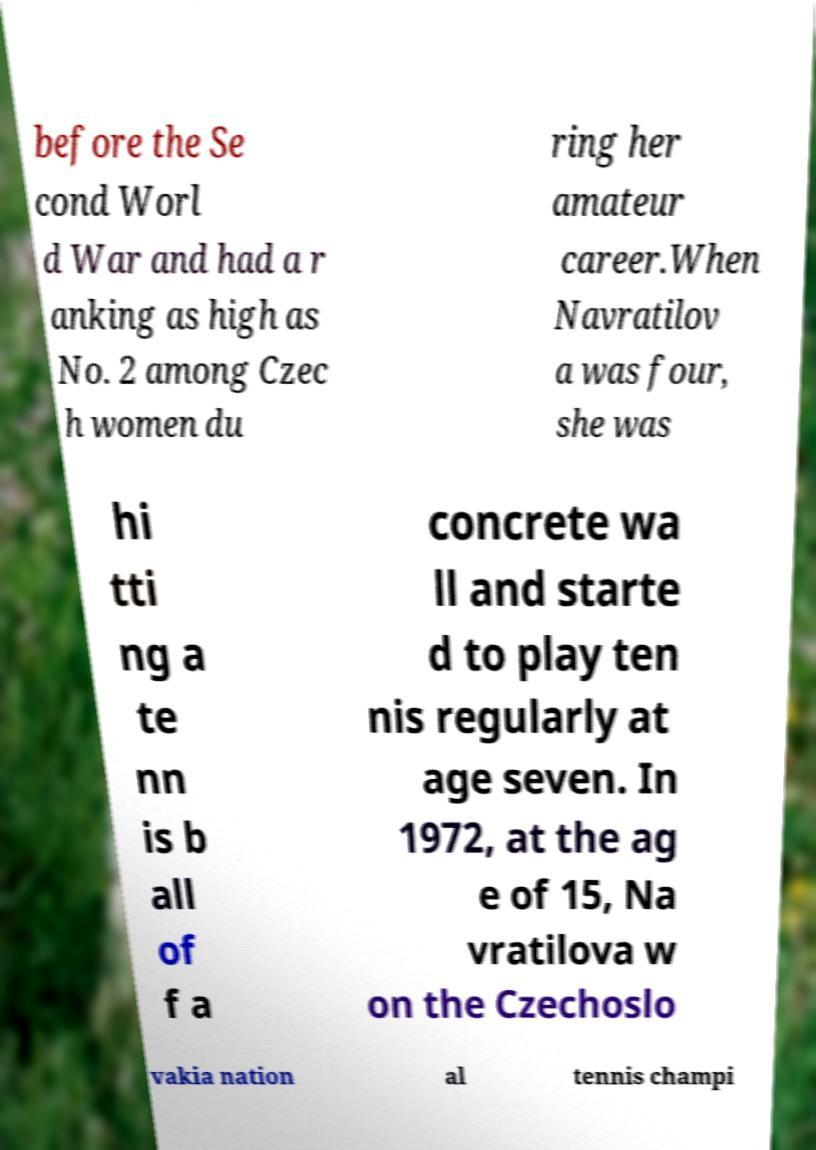There's text embedded in this image that I need extracted. Can you transcribe it verbatim? before the Se cond Worl d War and had a r anking as high as No. 2 among Czec h women du ring her amateur career.When Navratilov a was four, she was hi tti ng a te nn is b all of f a concrete wa ll and starte d to play ten nis regularly at age seven. In 1972, at the ag e of 15, Na vratilova w on the Czechoslo vakia nation al tennis champi 